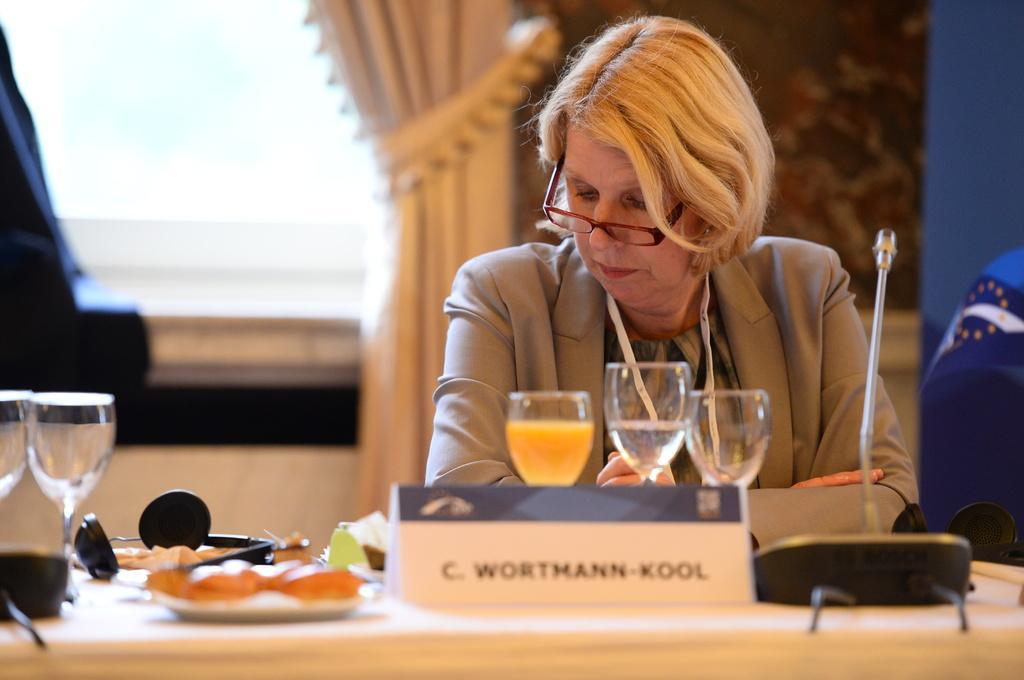How would you summarize this image in a sentence or two? In the image there is a woman in blond hair sitting in front of dining table with glasses,food,plates on it, in front of her there is mic and behind her there is window on the wall with curtain. 